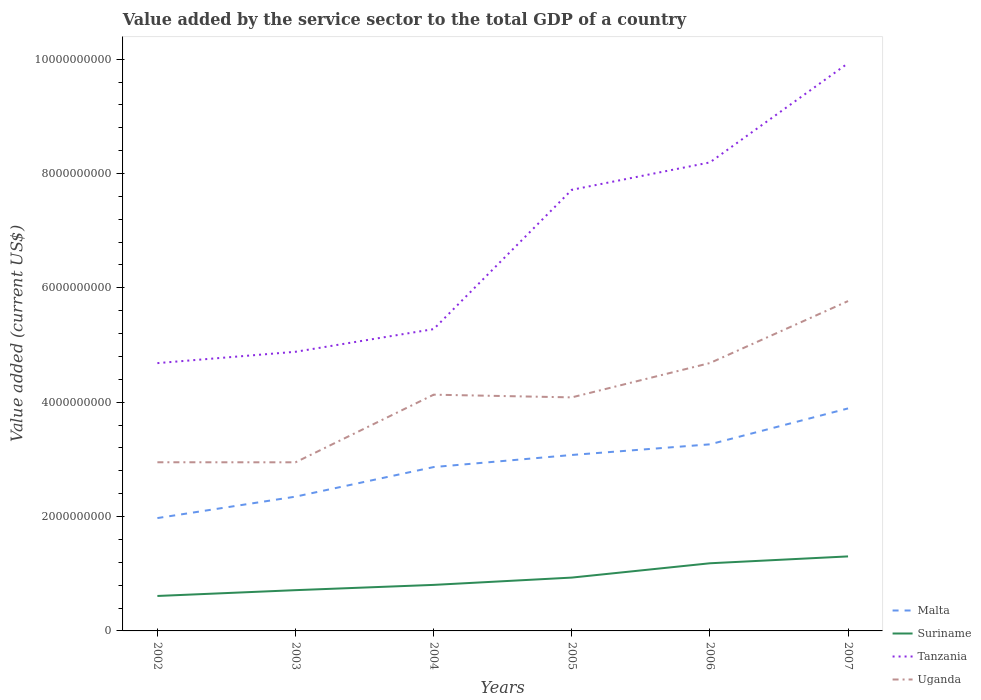Is the number of lines equal to the number of legend labels?
Your answer should be compact. Yes. Across all years, what is the maximum value added by the service sector to the total GDP in Uganda?
Make the answer very short. 2.95e+09. In which year was the value added by the service sector to the total GDP in Suriname maximum?
Your response must be concise. 2002. What is the total value added by the service sector to the total GDP in Suriname in the graph?
Make the answer very short. -3.70e+08. What is the difference between the highest and the second highest value added by the service sector to the total GDP in Malta?
Your answer should be very brief. 1.92e+09. What is the difference between the highest and the lowest value added by the service sector to the total GDP in Tanzania?
Offer a very short reply. 3. How many years are there in the graph?
Provide a succinct answer. 6. Does the graph contain any zero values?
Keep it short and to the point. No. Does the graph contain grids?
Offer a very short reply. No. How are the legend labels stacked?
Your answer should be very brief. Vertical. What is the title of the graph?
Make the answer very short. Value added by the service sector to the total GDP of a country. Does "Grenada" appear as one of the legend labels in the graph?
Keep it short and to the point. No. What is the label or title of the X-axis?
Keep it short and to the point. Years. What is the label or title of the Y-axis?
Your response must be concise. Value added (current US$). What is the Value added (current US$) of Malta in 2002?
Give a very brief answer. 1.97e+09. What is the Value added (current US$) of Suriname in 2002?
Give a very brief answer. 6.11e+08. What is the Value added (current US$) in Tanzania in 2002?
Your answer should be compact. 4.68e+09. What is the Value added (current US$) in Uganda in 2002?
Your answer should be compact. 2.95e+09. What is the Value added (current US$) of Malta in 2003?
Offer a very short reply. 2.35e+09. What is the Value added (current US$) of Suriname in 2003?
Provide a succinct answer. 7.13e+08. What is the Value added (current US$) in Tanzania in 2003?
Your answer should be very brief. 4.88e+09. What is the Value added (current US$) of Uganda in 2003?
Your response must be concise. 2.95e+09. What is the Value added (current US$) in Malta in 2004?
Your response must be concise. 2.87e+09. What is the Value added (current US$) in Suriname in 2004?
Offer a terse response. 8.05e+08. What is the Value added (current US$) of Tanzania in 2004?
Your answer should be compact. 5.28e+09. What is the Value added (current US$) of Uganda in 2004?
Your response must be concise. 4.13e+09. What is the Value added (current US$) in Malta in 2005?
Your answer should be compact. 3.08e+09. What is the Value added (current US$) of Suriname in 2005?
Your response must be concise. 9.33e+08. What is the Value added (current US$) of Tanzania in 2005?
Keep it short and to the point. 7.71e+09. What is the Value added (current US$) of Uganda in 2005?
Keep it short and to the point. 4.08e+09. What is the Value added (current US$) of Malta in 2006?
Give a very brief answer. 3.26e+09. What is the Value added (current US$) of Suriname in 2006?
Ensure brevity in your answer.  1.18e+09. What is the Value added (current US$) in Tanzania in 2006?
Ensure brevity in your answer.  8.19e+09. What is the Value added (current US$) of Uganda in 2006?
Give a very brief answer. 4.68e+09. What is the Value added (current US$) in Malta in 2007?
Provide a succinct answer. 3.89e+09. What is the Value added (current US$) in Suriname in 2007?
Give a very brief answer. 1.30e+09. What is the Value added (current US$) of Tanzania in 2007?
Make the answer very short. 9.93e+09. What is the Value added (current US$) of Uganda in 2007?
Your answer should be very brief. 5.77e+09. Across all years, what is the maximum Value added (current US$) of Malta?
Offer a terse response. 3.89e+09. Across all years, what is the maximum Value added (current US$) in Suriname?
Your response must be concise. 1.30e+09. Across all years, what is the maximum Value added (current US$) of Tanzania?
Keep it short and to the point. 9.93e+09. Across all years, what is the maximum Value added (current US$) in Uganda?
Keep it short and to the point. 5.77e+09. Across all years, what is the minimum Value added (current US$) in Malta?
Keep it short and to the point. 1.97e+09. Across all years, what is the minimum Value added (current US$) in Suriname?
Offer a terse response. 6.11e+08. Across all years, what is the minimum Value added (current US$) of Tanzania?
Make the answer very short. 4.68e+09. Across all years, what is the minimum Value added (current US$) of Uganda?
Offer a terse response. 2.95e+09. What is the total Value added (current US$) of Malta in the graph?
Keep it short and to the point. 1.74e+1. What is the total Value added (current US$) in Suriname in the graph?
Your answer should be very brief. 5.55e+09. What is the total Value added (current US$) of Tanzania in the graph?
Your response must be concise. 4.07e+1. What is the total Value added (current US$) in Uganda in the graph?
Your answer should be compact. 2.46e+1. What is the difference between the Value added (current US$) in Malta in 2002 and that in 2003?
Provide a short and direct response. -3.75e+08. What is the difference between the Value added (current US$) in Suriname in 2002 and that in 2003?
Give a very brief answer. -1.02e+08. What is the difference between the Value added (current US$) in Tanzania in 2002 and that in 2003?
Provide a short and direct response. -1.98e+08. What is the difference between the Value added (current US$) of Uganda in 2002 and that in 2003?
Offer a terse response. 7.68e+05. What is the difference between the Value added (current US$) of Malta in 2002 and that in 2004?
Your response must be concise. -8.92e+08. What is the difference between the Value added (current US$) in Suriname in 2002 and that in 2004?
Give a very brief answer. -1.94e+08. What is the difference between the Value added (current US$) of Tanzania in 2002 and that in 2004?
Your answer should be compact. -5.95e+08. What is the difference between the Value added (current US$) of Uganda in 2002 and that in 2004?
Your answer should be compact. -1.18e+09. What is the difference between the Value added (current US$) in Malta in 2002 and that in 2005?
Offer a very short reply. -1.10e+09. What is the difference between the Value added (current US$) in Suriname in 2002 and that in 2005?
Offer a terse response. -3.22e+08. What is the difference between the Value added (current US$) of Tanzania in 2002 and that in 2005?
Keep it short and to the point. -3.03e+09. What is the difference between the Value added (current US$) of Uganda in 2002 and that in 2005?
Keep it short and to the point. -1.13e+09. What is the difference between the Value added (current US$) of Malta in 2002 and that in 2006?
Offer a terse response. -1.29e+09. What is the difference between the Value added (current US$) in Suriname in 2002 and that in 2006?
Your answer should be compact. -5.72e+08. What is the difference between the Value added (current US$) in Tanzania in 2002 and that in 2006?
Make the answer very short. -3.51e+09. What is the difference between the Value added (current US$) of Uganda in 2002 and that in 2006?
Your answer should be very brief. -1.74e+09. What is the difference between the Value added (current US$) of Malta in 2002 and that in 2007?
Make the answer very short. -1.92e+09. What is the difference between the Value added (current US$) in Suriname in 2002 and that in 2007?
Your response must be concise. -6.92e+08. What is the difference between the Value added (current US$) of Tanzania in 2002 and that in 2007?
Your answer should be very brief. -5.25e+09. What is the difference between the Value added (current US$) of Uganda in 2002 and that in 2007?
Your answer should be very brief. -2.82e+09. What is the difference between the Value added (current US$) of Malta in 2003 and that in 2004?
Make the answer very short. -5.17e+08. What is the difference between the Value added (current US$) in Suriname in 2003 and that in 2004?
Ensure brevity in your answer.  -9.21e+07. What is the difference between the Value added (current US$) in Tanzania in 2003 and that in 2004?
Ensure brevity in your answer.  -3.96e+08. What is the difference between the Value added (current US$) in Uganda in 2003 and that in 2004?
Ensure brevity in your answer.  -1.18e+09. What is the difference between the Value added (current US$) of Malta in 2003 and that in 2005?
Your answer should be very brief. -7.28e+08. What is the difference between the Value added (current US$) in Suriname in 2003 and that in 2005?
Your answer should be very brief. -2.20e+08. What is the difference between the Value added (current US$) in Tanzania in 2003 and that in 2005?
Make the answer very short. -2.83e+09. What is the difference between the Value added (current US$) in Uganda in 2003 and that in 2005?
Provide a short and direct response. -1.14e+09. What is the difference between the Value added (current US$) of Malta in 2003 and that in 2006?
Provide a short and direct response. -9.15e+08. What is the difference between the Value added (current US$) of Suriname in 2003 and that in 2006?
Provide a succinct answer. -4.70e+08. What is the difference between the Value added (current US$) of Tanzania in 2003 and that in 2006?
Make the answer very short. -3.31e+09. What is the difference between the Value added (current US$) in Uganda in 2003 and that in 2006?
Your answer should be very brief. -1.74e+09. What is the difference between the Value added (current US$) in Malta in 2003 and that in 2007?
Give a very brief answer. -1.54e+09. What is the difference between the Value added (current US$) in Suriname in 2003 and that in 2007?
Offer a terse response. -5.90e+08. What is the difference between the Value added (current US$) of Tanzania in 2003 and that in 2007?
Offer a terse response. -5.05e+09. What is the difference between the Value added (current US$) in Uganda in 2003 and that in 2007?
Your answer should be very brief. -2.82e+09. What is the difference between the Value added (current US$) in Malta in 2004 and that in 2005?
Offer a very short reply. -2.11e+08. What is the difference between the Value added (current US$) of Suriname in 2004 and that in 2005?
Keep it short and to the point. -1.28e+08. What is the difference between the Value added (current US$) of Tanzania in 2004 and that in 2005?
Provide a short and direct response. -2.44e+09. What is the difference between the Value added (current US$) of Uganda in 2004 and that in 2005?
Ensure brevity in your answer.  4.72e+07. What is the difference between the Value added (current US$) of Malta in 2004 and that in 2006?
Offer a very short reply. -3.98e+08. What is the difference between the Value added (current US$) in Suriname in 2004 and that in 2006?
Your answer should be very brief. -3.78e+08. What is the difference between the Value added (current US$) in Tanzania in 2004 and that in 2006?
Your response must be concise. -2.92e+09. What is the difference between the Value added (current US$) in Uganda in 2004 and that in 2006?
Ensure brevity in your answer.  -5.53e+08. What is the difference between the Value added (current US$) of Malta in 2004 and that in 2007?
Offer a terse response. -1.03e+09. What is the difference between the Value added (current US$) in Suriname in 2004 and that in 2007?
Offer a terse response. -4.98e+08. What is the difference between the Value added (current US$) in Tanzania in 2004 and that in 2007?
Make the answer very short. -4.65e+09. What is the difference between the Value added (current US$) of Uganda in 2004 and that in 2007?
Make the answer very short. -1.64e+09. What is the difference between the Value added (current US$) in Malta in 2005 and that in 2006?
Your answer should be compact. -1.86e+08. What is the difference between the Value added (current US$) in Suriname in 2005 and that in 2006?
Your answer should be compact. -2.50e+08. What is the difference between the Value added (current US$) in Tanzania in 2005 and that in 2006?
Ensure brevity in your answer.  -4.79e+08. What is the difference between the Value added (current US$) of Uganda in 2005 and that in 2006?
Offer a terse response. -6.01e+08. What is the difference between the Value added (current US$) of Malta in 2005 and that in 2007?
Give a very brief answer. -8.14e+08. What is the difference between the Value added (current US$) in Suriname in 2005 and that in 2007?
Give a very brief answer. -3.70e+08. What is the difference between the Value added (current US$) of Tanzania in 2005 and that in 2007?
Keep it short and to the point. -2.21e+09. What is the difference between the Value added (current US$) in Uganda in 2005 and that in 2007?
Provide a short and direct response. -1.68e+09. What is the difference between the Value added (current US$) of Malta in 2006 and that in 2007?
Ensure brevity in your answer.  -6.28e+08. What is the difference between the Value added (current US$) in Suriname in 2006 and that in 2007?
Your answer should be compact. -1.20e+08. What is the difference between the Value added (current US$) of Tanzania in 2006 and that in 2007?
Provide a short and direct response. -1.73e+09. What is the difference between the Value added (current US$) of Uganda in 2006 and that in 2007?
Give a very brief answer. -1.08e+09. What is the difference between the Value added (current US$) in Malta in 2002 and the Value added (current US$) in Suriname in 2003?
Ensure brevity in your answer.  1.26e+09. What is the difference between the Value added (current US$) in Malta in 2002 and the Value added (current US$) in Tanzania in 2003?
Offer a very short reply. -2.91e+09. What is the difference between the Value added (current US$) in Malta in 2002 and the Value added (current US$) in Uganda in 2003?
Your answer should be compact. -9.75e+08. What is the difference between the Value added (current US$) of Suriname in 2002 and the Value added (current US$) of Tanzania in 2003?
Your answer should be compact. -4.27e+09. What is the difference between the Value added (current US$) in Suriname in 2002 and the Value added (current US$) in Uganda in 2003?
Provide a succinct answer. -2.34e+09. What is the difference between the Value added (current US$) in Tanzania in 2002 and the Value added (current US$) in Uganda in 2003?
Your answer should be compact. 1.73e+09. What is the difference between the Value added (current US$) in Malta in 2002 and the Value added (current US$) in Suriname in 2004?
Your response must be concise. 1.17e+09. What is the difference between the Value added (current US$) of Malta in 2002 and the Value added (current US$) of Tanzania in 2004?
Your response must be concise. -3.30e+09. What is the difference between the Value added (current US$) of Malta in 2002 and the Value added (current US$) of Uganda in 2004?
Your answer should be very brief. -2.16e+09. What is the difference between the Value added (current US$) of Suriname in 2002 and the Value added (current US$) of Tanzania in 2004?
Your answer should be very brief. -4.67e+09. What is the difference between the Value added (current US$) in Suriname in 2002 and the Value added (current US$) in Uganda in 2004?
Keep it short and to the point. -3.52e+09. What is the difference between the Value added (current US$) of Tanzania in 2002 and the Value added (current US$) of Uganda in 2004?
Your response must be concise. 5.52e+08. What is the difference between the Value added (current US$) in Malta in 2002 and the Value added (current US$) in Suriname in 2005?
Your answer should be very brief. 1.04e+09. What is the difference between the Value added (current US$) of Malta in 2002 and the Value added (current US$) of Tanzania in 2005?
Your answer should be compact. -5.74e+09. What is the difference between the Value added (current US$) of Malta in 2002 and the Value added (current US$) of Uganda in 2005?
Provide a short and direct response. -2.11e+09. What is the difference between the Value added (current US$) of Suriname in 2002 and the Value added (current US$) of Tanzania in 2005?
Offer a terse response. -7.10e+09. What is the difference between the Value added (current US$) of Suriname in 2002 and the Value added (current US$) of Uganda in 2005?
Make the answer very short. -3.47e+09. What is the difference between the Value added (current US$) of Tanzania in 2002 and the Value added (current US$) of Uganda in 2005?
Offer a terse response. 5.99e+08. What is the difference between the Value added (current US$) in Malta in 2002 and the Value added (current US$) in Suriname in 2006?
Give a very brief answer. 7.90e+08. What is the difference between the Value added (current US$) in Malta in 2002 and the Value added (current US$) in Tanzania in 2006?
Offer a terse response. -6.22e+09. What is the difference between the Value added (current US$) in Malta in 2002 and the Value added (current US$) in Uganda in 2006?
Offer a very short reply. -2.71e+09. What is the difference between the Value added (current US$) in Suriname in 2002 and the Value added (current US$) in Tanzania in 2006?
Your answer should be very brief. -7.58e+09. What is the difference between the Value added (current US$) in Suriname in 2002 and the Value added (current US$) in Uganda in 2006?
Provide a succinct answer. -4.07e+09. What is the difference between the Value added (current US$) in Tanzania in 2002 and the Value added (current US$) in Uganda in 2006?
Your response must be concise. -1.42e+06. What is the difference between the Value added (current US$) in Malta in 2002 and the Value added (current US$) in Suriname in 2007?
Provide a succinct answer. 6.70e+08. What is the difference between the Value added (current US$) of Malta in 2002 and the Value added (current US$) of Tanzania in 2007?
Provide a succinct answer. -7.96e+09. What is the difference between the Value added (current US$) of Malta in 2002 and the Value added (current US$) of Uganda in 2007?
Make the answer very short. -3.79e+09. What is the difference between the Value added (current US$) of Suriname in 2002 and the Value added (current US$) of Tanzania in 2007?
Give a very brief answer. -9.32e+09. What is the difference between the Value added (current US$) in Suriname in 2002 and the Value added (current US$) in Uganda in 2007?
Your answer should be compact. -5.16e+09. What is the difference between the Value added (current US$) in Tanzania in 2002 and the Value added (current US$) in Uganda in 2007?
Your answer should be compact. -1.09e+09. What is the difference between the Value added (current US$) of Malta in 2003 and the Value added (current US$) of Suriname in 2004?
Your answer should be compact. 1.54e+09. What is the difference between the Value added (current US$) of Malta in 2003 and the Value added (current US$) of Tanzania in 2004?
Make the answer very short. -2.93e+09. What is the difference between the Value added (current US$) in Malta in 2003 and the Value added (current US$) in Uganda in 2004?
Provide a succinct answer. -1.78e+09. What is the difference between the Value added (current US$) of Suriname in 2003 and the Value added (current US$) of Tanzania in 2004?
Offer a terse response. -4.57e+09. What is the difference between the Value added (current US$) of Suriname in 2003 and the Value added (current US$) of Uganda in 2004?
Your answer should be very brief. -3.42e+09. What is the difference between the Value added (current US$) of Tanzania in 2003 and the Value added (current US$) of Uganda in 2004?
Offer a terse response. 7.50e+08. What is the difference between the Value added (current US$) of Malta in 2003 and the Value added (current US$) of Suriname in 2005?
Provide a short and direct response. 1.42e+09. What is the difference between the Value added (current US$) in Malta in 2003 and the Value added (current US$) in Tanzania in 2005?
Your response must be concise. -5.37e+09. What is the difference between the Value added (current US$) in Malta in 2003 and the Value added (current US$) in Uganda in 2005?
Your answer should be very brief. -1.74e+09. What is the difference between the Value added (current US$) of Suriname in 2003 and the Value added (current US$) of Tanzania in 2005?
Give a very brief answer. -7.00e+09. What is the difference between the Value added (current US$) in Suriname in 2003 and the Value added (current US$) in Uganda in 2005?
Keep it short and to the point. -3.37e+09. What is the difference between the Value added (current US$) in Tanzania in 2003 and the Value added (current US$) in Uganda in 2005?
Your response must be concise. 7.98e+08. What is the difference between the Value added (current US$) in Malta in 2003 and the Value added (current US$) in Suriname in 2006?
Your response must be concise. 1.17e+09. What is the difference between the Value added (current US$) in Malta in 2003 and the Value added (current US$) in Tanzania in 2006?
Offer a very short reply. -5.85e+09. What is the difference between the Value added (current US$) of Malta in 2003 and the Value added (current US$) of Uganda in 2006?
Make the answer very short. -2.34e+09. What is the difference between the Value added (current US$) in Suriname in 2003 and the Value added (current US$) in Tanzania in 2006?
Ensure brevity in your answer.  -7.48e+09. What is the difference between the Value added (current US$) of Suriname in 2003 and the Value added (current US$) of Uganda in 2006?
Offer a very short reply. -3.97e+09. What is the difference between the Value added (current US$) of Tanzania in 2003 and the Value added (current US$) of Uganda in 2006?
Provide a short and direct response. 1.97e+08. What is the difference between the Value added (current US$) of Malta in 2003 and the Value added (current US$) of Suriname in 2007?
Your answer should be very brief. 1.05e+09. What is the difference between the Value added (current US$) in Malta in 2003 and the Value added (current US$) in Tanzania in 2007?
Your answer should be very brief. -7.58e+09. What is the difference between the Value added (current US$) in Malta in 2003 and the Value added (current US$) in Uganda in 2007?
Give a very brief answer. -3.42e+09. What is the difference between the Value added (current US$) of Suriname in 2003 and the Value added (current US$) of Tanzania in 2007?
Offer a terse response. -9.22e+09. What is the difference between the Value added (current US$) of Suriname in 2003 and the Value added (current US$) of Uganda in 2007?
Your response must be concise. -5.06e+09. What is the difference between the Value added (current US$) of Tanzania in 2003 and the Value added (current US$) of Uganda in 2007?
Provide a short and direct response. -8.87e+08. What is the difference between the Value added (current US$) of Malta in 2004 and the Value added (current US$) of Suriname in 2005?
Keep it short and to the point. 1.93e+09. What is the difference between the Value added (current US$) of Malta in 2004 and the Value added (current US$) of Tanzania in 2005?
Offer a terse response. -4.85e+09. What is the difference between the Value added (current US$) in Malta in 2004 and the Value added (current US$) in Uganda in 2005?
Provide a succinct answer. -1.22e+09. What is the difference between the Value added (current US$) of Suriname in 2004 and the Value added (current US$) of Tanzania in 2005?
Ensure brevity in your answer.  -6.91e+09. What is the difference between the Value added (current US$) of Suriname in 2004 and the Value added (current US$) of Uganda in 2005?
Your answer should be compact. -3.28e+09. What is the difference between the Value added (current US$) of Tanzania in 2004 and the Value added (current US$) of Uganda in 2005?
Provide a short and direct response. 1.19e+09. What is the difference between the Value added (current US$) in Malta in 2004 and the Value added (current US$) in Suriname in 2006?
Ensure brevity in your answer.  1.68e+09. What is the difference between the Value added (current US$) of Malta in 2004 and the Value added (current US$) of Tanzania in 2006?
Offer a very short reply. -5.33e+09. What is the difference between the Value added (current US$) in Malta in 2004 and the Value added (current US$) in Uganda in 2006?
Ensure brevity in your answer.  -1.82e+09. What is the difference between the Value added (current US$) of Suriname in 2004 and the Value added (current US$) of Tanzania in 2006?
Keep it short and to the point. -7.39e+09. What is the difference between the Value added (current US$) in Suriname in 2004 and the Value added (current US$) in Uganda in 2006?
Offer a very short reply. -3.88e+09. What is the difference between the Value added (current US$) in Tanzania in 2004 and the Value added (current US$) in Uganda in 2006?
Ensure brevity in your answer.  5.93e+08. What is the difference between the Value added (current US$) of Malta in 2004 and the Value added (current US$) of Suriname in 2007?
Ensure brevity in your answer.  1.56e+09. What is the difference between the Value added (current US$) of Malta in 2004 and the Value added (current US$) of Tanzania in 2007?
Keep it short and to the point. -7.06e+09. What is the difference between the Value added (current US$) of Malta in 2004 and the Value added (current US$) of Uganda in 2007?
Provide a succinct answer. -2.90e+09. What is the difference between the Value added (current US$) in Suriname in 2004 and the Value added (current US$) in Tanzania in 2007?
Make the answer very short. -9.12e+09. What is the difference between the Value added (current US$) in Suriname in 2004 and the Value added (current US$) in Uganda in 2007?
Ensure brevity in your answer.  -4.96e+09. What is the difference between the Value added (current US$) of Tanzania in 2004 and the Value added (current US$) of Uganda in 2007?
Keep it short and to the point. -4.90e+08. What is the difference between the Value added (current US$) in Malta in 2005 and the Value added (current US$) in Suriname in 2006?
Keep it short and to the point. 1.89e+09. What is the difference between the Value added (current US$) of Malta in 2005 and the Value added (current US$) of Tanzania in 2006?
Provide a short and direct response. -5.12e+09. What is the difference between the Value added (current US$) of Malta in 2005 and the Value added (current US$) of Uganda in 2006?
Provide a short and direct response. -1.61e+09. What is the difference between the Value added (current US$) in Suriname in 2005 and the Value added (current US$) in Tanzania in 2006?
Offer a terse response. -7.26e+09. What is the difference between the Value added (current US$) of Suriname in 2005 and the Value added (current US$) of Uganda in 2006?
Offer a terse response. -3.75e+09. What is the difference between the Value added (current US$) of Tanzania in 2005 and the Value added (current US$) of Uganda in 2006?
Your response must be concise. 3.03e+09. What is the difference between the Value added (current US$) of Malta in 2005 and the Value added (current US$) of Suriname in 2007?
Offer a terse response. 1.77e+09. What is the difference between the Value added (current US$) in Malta in 2005 and the Value added (current US$) in Tanzania in 2007?
Keep it short and to the point. -6.85e+09. What is the difference between the Value added (current US$) in Malta in 2005 and the Value added (current US$) in Uganda in 2007?
Your response must be concise. -2.69e+09. What is the difference between the Value added (current US$) of Suriname in 2005 and the Value added (current US$) of Tanzania in 2007?
Offer a terse response. -9.00e+09. What is the difference between the Value added (current US$) of Suriname in 2005 and the Value added (current US$) of Uganda in 2007?
Keep it short and to the point. -4.84e+09. What is the difference between the Value added (current US$) of Tanzania in 2005 and the Value added (current US$) of Uganda in 2007?
Offer a terse response. 1.95e+09. What is the difference between the Value added (current US$) of Malta in 2006 and the Value added (current US$) of Suriname in 2007?
Keep it short and to the point. 1.96e+09. What is the difference between the Value added (current US$) in Malta in 2006 and the Value added (current US$) in Tanzania in 2007?
Your answer should be compact. -6.67e+09. What is the difference between the Value added (current US$) in Malta in 2006 and the Value added (current US$) in Uganda in 2007?
Offer a terse response. -2.51e+09. What is the difference between the Value added (current US$) of Suriname in 2006 and the Value added (current US$) of Tanzania in 2007?
Ensure brevity in your answer.  -8.75e+09. What is the difference between the Value added (current US$) of Suriname in 2006 and the Value added (current US$) of Uganda in 2007?
Your answer should be compact. -4.59e+09. What is the difference between the Value added (current US$) of Tanzania in 2006 and the Value added (current US$) of Uganda in 2007?
Offer a terse response. 2.43e+09. What is the average Value added (current US$) in Malta per year?
Your answer should be compact. 2.90e+09. What is the average Value added (current US$) of Suriname per year?
Keep it short and to the point. 9.25e+08. What is the average Value added (current US$) of Tanzania per year?
Your answer should be very brief. 6.78e+09. What is the average Value added (current US$) in Uganda per year?
Ensure brevity in your answer.  4.09e+09. In the year 2002, what is the difference between the Value added (current US$) in Malta and Value added (current US$) in Suriname?
Provide a succinct answer. 1.36e+09. In the year 2002, what is the difference between the Value added (current US$) of Malta and Value added (current US$) of Tanzania?
Offer a terse response. -2.71e+09. In the year 2002, what is the difference between the Value added (current US$) of Malta and Value added (current US$) of Uganda?
Ensure brevity in your answer.  -9.76e+08. In the year 2002, what is the difference between the Value added (current US$) of Suriname and Value added (current US$) of Tanzania?
Your answer should be very brief. -4.07e+09. In the year 2002, what is the difference between the Value added (current US$) in Suriname and Value added (current US$) in Uganda?
Your answer should be very brief. -2.34e+09. In the year 2002, what is the difference between the Value added (current US$) of Tanzania and Value added (current US$) of Uganda?
Keep it short and to the point. 1.73e+09. In the year 2003, what is the difference between the Value added (current US$) in Malta and Value added (current US$) in Suriname?
Offer a terse response. 1.64e+09. In the year 2003, what is the difference between the Value added (current US$) of Malta and Value added (current US$) of Tanzania?
Give a very brief answer. -2.53e+09. In the year 2003, what is the difference between the Value added (current US$) in Malta and Value added (current US$) in Uganda?
Ensure brevity in your answer.  -6.00e+08. In the year 2003, what is the difference between the Value added (current US$) in Suriname and Value added (current US$) in Tanzania?
Make the answer very short. -4.17e+09. In the year 2003, what is the difference between the Value added (current US$) in Suriname and Value added (current US$) in Uganda?
Provide a short and direct response. -2.24e+09. In the year 2003, what is the difference between the Value added (current US$) of Tanzania and Value added (current US$) of Uganda?
Give a very brief answer. 1.93e+09. In the year 2004, what is the difference between the Value added (current US$) of Malta and Value added (current US$) of Suriname?
Give a very brief answer. 2.06e+09. In the year 2004, what is the difference between the Value added (current US$) of Malta and Value added (current US$) of Tanzania?
Your answer should be very brief. -2.41e+09. In the year 2004, what is the difference between the Value added (current US$) of Malta and Value added (current US$) of Uganda?
Provide a succinct answer. -1.27e+09. In the year 2004, what is the difference between the Value added (current US$) of Suriname and Value added (current US$) of Tanzania?
Give a very brief answer. -4.47e+09. In the year 2004, what is the difference between the Value added (current US$) in Suriname and Value added (current US$) in Uganda?
Provide a short and direct response. -3.33e+09. In the year 2004, what is the difference between the Value added (current US$) in Tanzania and Value added (current US$) in Uganda?
Your answer should be compact. 1.15e+09. In the year 2005, what is the difference between the Value added (current US$) of Malta and Value added (current US$) of Suriname?
Keep it short and to the point. 2.14e+09. In the year 2005, what is the difference between the Value added (current US$) in Malta and Value added (current US$) in Tanzania?
Your answer should be compact. -4.64e+09. In the year 2005, what is the difference between the Value added (current US$) in Malta and Value added (current US$) in Uganda?
Your answer should be compact. -1.01e+09. In the year 2005, what is the difference between the Value added (current US$) of Suriname and Value added (current US$) of Tanzania?
Give a very brief answer. -6.78e+09. In the year 2005, what is the difference between the Value added (current US$) of Suriname and Value added (current US$) of Uganda?
Your response must be concise. -3.15e+09. In the year 2005, what is the difference between the Value added (current US$) of Tanzania and Value added (current US$) of Uganda?
Ensure brevity in your answer.  3.63e+09. In the year 2006, what is the difference between the Value added (current US$) in Malta and Value added (current US$) in Suriname?
Offer a terse response. 2.08e+09. In the year 2006, what is the difference between the Value added (current US$) of Malta and Value added (current US$) of Tanzania?
Provide a succinct answer. -4.93e+09. In the year 2006, what is the difference between the Value added (current US$) of Malta and Value added (current US$) of Uganda?
Your response must be concise. -1.42e+09. In the year 2006, what is the difference between the Value added (current US$) of Suriname and Value added (current US$) of Tanzania?
Offer a very short reply. -7.01e+09. In the year 2006, what is the difference between the Value added (current US$) of Suriname and Value added (current US$) of Uganda?
Your answer should be compact. -3.50e+09. In the year 2006, what is the difference between the Value added (current US$) of Tanzania and Value added (current US$) of Uganda?
Provide a short and direct response. 3.51e+09. In the year 2007, what is the difference between the Value added (current US$) in Malta and Value added (current US$) in Suriname?
Ensure brevity in your answer.  2.59e+09. In the year 2007, what is the difference between the Value added (current US$) of Malta and Value added (current US$) of Tanzania?
Your response must be concise. -6.04e+09. In the year 2007, what is the difference between the Value added (current US$) in Malta and Value added (current US$) in Uganda?
Give a very brief answer. -1.88e+09. In the year 2007, what is the difference between the Value added (current US$) of Suriname and Value added (current US$) of Tanzania?
Offer a very short reply. -8.63e+09. In the year 2007, what is the difference between the Value added (current US$) in Suriname and Value added (current US$) in Uganda?
Your answer should be compact. -4.47e+09. In the year 2007, what is the difference between the Value added (current US$) in Tanzania and Value added (current US$) in Uganda?
Ensure brevity in your answer.  4.16e+09. What is the ratio of the Value added (current US$) in Malta in 2002 to that in 2003?
Ensure brevity in your answer.  0.84. What is the ratio of the Value added (current US$) in Suriname in 2002 to that in 2003?
Ensure brevity in your answer.  0.86. What is the ratio of the Value added (current US$) in Tanzania in 2002 to that in 2003?
Make the answer very short. 0.96. What is the ratio of the Value added (current US$) in Malta in 2002 to that in 2004?
Offer a very short reply. 0.69. What is the ratio of the Value added (current US$) of Suriname in 2002 to that in 2004?
Keep it short and to the point. 0.76. What is the ratio of the Value added (current US$) of Tanzania in 2002 to that in 2004?
Your answer should be compact. 0.89. What is the ratio of the Value added (current US$) of Uganda in 2002 to that in 2004?
Keep it short and to the point. 0.71. What is the ratio of the Value added (current US$) in Malta in 2002 to that in 2005?
Ensure brevity in your answer.  0.64. What is the ratio of the Value added (current US$) of Suriname in 2002 to that in 2005?
Ensure brevity in your answer.  0.66. What is the ratio of the Value added (current US$) of Tanzania in 2002 to that in 2005?
Your response must be concise. 0.61. What is the ratio of the Value added (current US$) of Uganda in 2002 to that in 2005?
Make the answer very short. 0.72. What is the ratio of the Value added (current US$) of Malta in 2002 to that in 2006?
Keep it short and to the point. 0.6. What is the ratio of the Value added (current US$) in Suriname in 2002 to that in 2006?
Give a very brief answer. 0.52. What is the ratio of the Value added (current US$) in Tanzania in 2002 to that in 2006?
Keep it short and to the point. 0.57. What is the ratio of the Value added (current US$) in Uganda in 2002 to that in 2006?
Give a very brief answer. 0.63. What is the ratio of the Value added (current US$) in Malta in 2002 to that in 2007?
Make the answer very short. 0.51. What is the ratio of the Value added (current US$) in Suriname in 2002 to that in 2007?
Your response must be concise. 0.47. What is the ratio of the Value added (current US$) in Tanzania in 2002 to that in 2007?
Make the answer very short. 0.47. What is the ratio of the Value added (current US$) of Uganda in 2002 to that in 2007?
Provide a succinct answer. 0.51. What is the ratio of the Value added (current US$) of Malta in 2003 to that in 2004?
Your answer should be very brief. 0.82. What is the ratio of the Value added (current US$) in Suriname in 2003 to that in 2004?
Keep it short and to the point. 0.89. What is the ratio of the Value added (current US$) in Tanzania in 2003 to that in 2004?
Your response must be concise. 0.92. What is the ratio of the Value added (current US$) in Uganda in 2003 to that in 2004?
Keep it short and to the point. 0.71. What is the ratio of the Value added (current US$) in Malta in 2003 to that in 2005?
Give a very brief answer. 0.76. What is the ratio of the Value added (current US$) in Suriname in 2003 to that in 2005?
Your answer should be compact. 0.76. What is the ratio of the Value added (current US$) in Tanzania in 2003 to that in 2005?
Offer a terse response. 0.63. What is the ratio of the Value added (current US$) in Uganda in 2003 to that in 2005?
Ensure brevity in your answer.  0.72. What is the ratio of the Value added (current US$) of Malta in 2003 to that in 2006?
Make the answer very short. 0.72. What is the ratio of the Value added (current US$) of Suriname in 2003 to that in 2006?
Your answer should be very brief. 0.6. What is the ratio of the Value added (current US$) in Tanzania in 2003 to that in 2006?
Offer a very short reply. 0.6. What is the ratio of the Value added (current US$) of Uganda in 2003 to that in 2006?
Ensure brevity in your answer.  0.63. What is the ratio of the Value added (current US$) in Malta in 2003 to that in 2007?
Make the answer very short. 0.6. What is the ratio of the Value added (current US$) in Suriname in 2003 to that in 2007?
Your answer should be very brief. 0.55. What is the ratio of the Value added (current US$) of Tanzania in 2003 to that in 2007?
Give a very brief answer. 0.49. What is the ratio of the Value added (current US$) in Uganda in 2003 to that in 2007?
Your answer should be compact. 0.51. What is the ratio of the Value added (current US$) in Malta in 2004 to that in 2005?
Your answer should be compact. 0.93. What is the ratio of the Value added (current US$) in Suriname in 2004 to that in 2005?
Give a very brief answer. 0.86. What is the ratio of the Value added (current US$) of Tanzania in 2004 to that in 2005?
Keep it short and to the point. 0.68. What is the ratio of the Value added (current US$) in Uganda in 2004 to that in 2005?
Provide a succinct answer. 1.01. What is the ratio of the Value added (current US$) of Malta in 2004 to that in 2006?
Your answer should be compact. 0.88. What is the ratio of the Value added (current US$) of Suriname in 2004 to that in 2006?
Offer a very short reply. 0.68. What is the ratio of the Value added (current US$) in Tanzania in 2004 to that in 2006?
Your response must be concise. 0.64. What is the ratio of the Value added (current US$) in Uganda in 2004 to that in 2006?
Your answer should be very brief. 0.88. What is the ratio of the Value added (current US$) of Malta in 2004 to that in 2007?
Your answer should be very brief. 0.74. What is the ratio of the Value added (current US$) in Suriname in 2004 to that in 2007?
Your answer should be very brief. 0.62. What is the ratio of the Value added (current US$) of Tanzania in 2004 to that in 2007?
Your answer should be compact. 0.53. What is the ratio of the Value added (current US$) of Uganda in 2004 to that in 2007?
Give a very brief answer. 0.72. What is the ratio of the Value added (current US$) of Malta in 2005 to that in 2006?
Give a very brief answer. 0.94. What is the ratio of the Value added (current US$) in Suriname in 2005 to that in 2006?
Offer a terse response. 0.79. What is the ratio of the Value added (current US$) in Tanzania in 2005 to that in 2006?
Make the answer very short. 0.94. What is the ratio of the Value added (current US$) of Uganda in 2005 to that in 2006?
Provide a short and direct response. 0.87. What is the ratio of the Value added (current US$) of Malta in 2005 to that in 2007?
Make the answer very short. 0.79. What is the ratio of the Value added (current US$) of Suriname in 2005 to that in 2007?
Ensure brevity in your answer.  0.72. What is the ratio of the Value added (current US$) of Tanzania in 2005 to that in 2007?
Your answer should be compact. 0.78. What is the ratio of the Value added (current US$) in Uganda in 2005 to that in 2007?
Offer a very short reply. 0.71. What is the ratio of the Value added (current US$) of Malta in 2006 to that in 2007?
Ensure brevity in your answer.  0.84. What is the ratio of the Value added (current US$) of Suriname in 2006 to that in 2007?
Keep it short and to the point. 0.91. What is the ratio of the Value added (current US$) in Tanzania in 2006 to that in 2007?
Give a very brief answer. 0.83. What is the ratio of the Value added (current US$) of Uganda in 2006 to that in 2007?
Offer a very short reply. 0.81. What is the difference between the highest and the second highest Value added (current US$) in Malta?
Give a very brief answer. 6.28e+08. What is the difference between the highest and the second highest Value added (current US$) in Suriname?
Offer a terse response. 1.20e+08. What is the difference between the highest and the second highest Value added (current US$) in Tanzania?
Keep it short and to the point. 1.73e+09. What is the difference between the highest and the second highest Value added (current US$) of Uganda?
Your answer should be very brief. 1.08e+09. What is the difference between the highest and the lowest Value added (current US$) of Malta?
Give a very brief answer. 1.92e+09. What is the difference between the highest and the lowest Value added (current US$) of Suriname?
Provide a short and direct response. 6.92e+08. What is the difference between the highest and the lowest Value added (current US$) in Tanzania?
Your answer should be very brief. 5.25e+09. What is the difference between the highest and the lowest Value added (current US$) of Uganda?
Ensure brevity in your answer.  2.82e+09. 